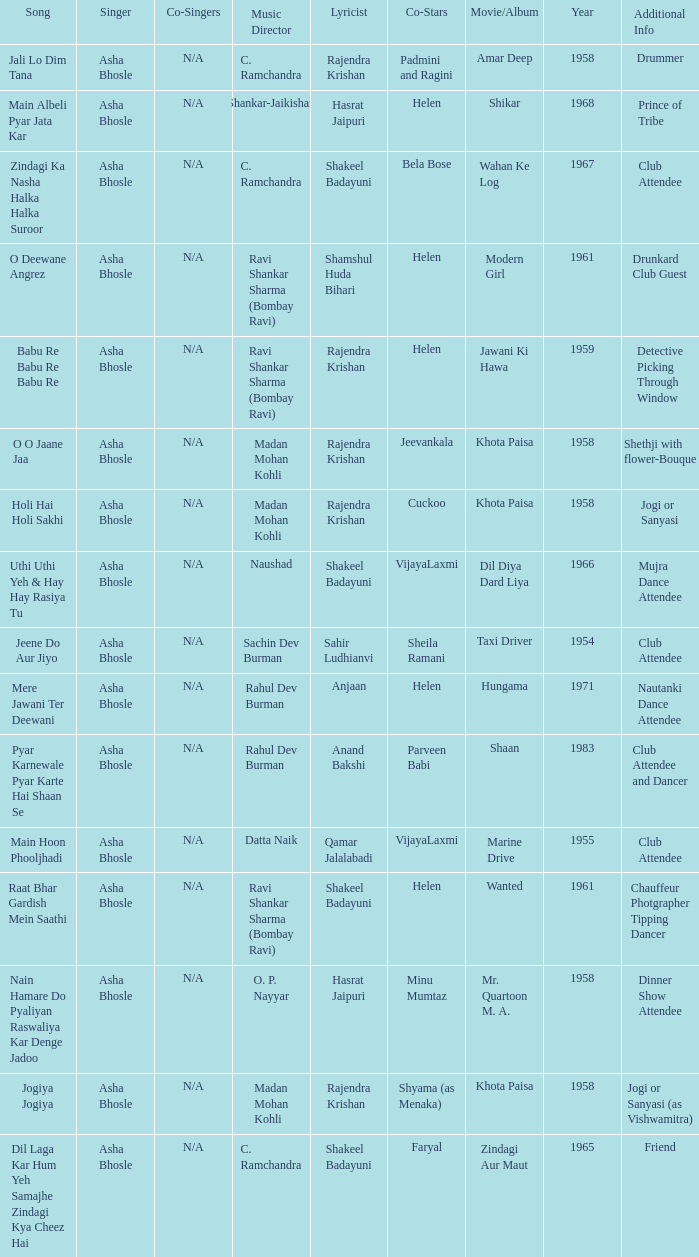What movie did Vijayalaxmi Co-star in and Shakeel Badayuni write the lyrics? Dil Diya Dard Liya. Parse the full table. {'header': ['Song', 'Singer', 'Co-Singers', 'Music Director', 'Lyricist', 'Co-Stars', 'Movie/Album', 'Year', 'Additional Info'], 'rows': [['Jali Lo Dim Tana', 'Asha Bhosle', 'N/A', 'C. Ramchandra', 'Rajendra Krishan', 'Padmini and Ragini', 'Amar Deep', '1958', 'Drummer'], ['Main Albeli Pyar Jata Kar', 'Asha Bhosle', 'N/A', 'Shankar-Jaikishan', 'Hasrat Jaipuri', 'Helen', 'Shikar', '1968', 'Prince of Tribe'], ['Zindagi Ka Nasha Halka Halka Suroor', 'Asha Bhosle', 'N/A', 'C. Ramchandra', 'Shakeel Badayuni', 'Bela Bose', 'Wahan Ke Log', '1967', 'Club Attendee'], ['O Deewane Angrez', 'Asha Bhosle', 'N/A', 'Ravi Shankar Sharma (Bombay Ravi)', 'Shamshul Huda Bihari', 'Helen', 'Modern Girl', '1961', 'Drunkard Club Guest'], ['Babu Re Babu Re Babu Re', 'Asha Bhosle', 'N/A', 'Ravi Shankar Sharma (Bombay Ravi)', 'Rajendra Krishan', 'Helen', 'Jawani Ki Hawa', '1959', 'Detective Picking Through Window'], ['O O Jaane Jaa', 'Asha Bhosle', 'N/A', 'Madan Mohan Kohli', 'Rajendra Krishan', 'Jeevankala', 'Khota Paisa', '1958', 'Shethji with flower-Bouque'], ['Holi Hai Holi Sakhi', 'Asha Bhosle', 'N/A', 'Madan Mohan Kohli', 'Rajendra Krishan', 'Cuckoo', 'Khota Paisa', '1958', 'Jogi or Sanyasi'], ['Uthi Uthi Yeh & Hay Hay Rasiya Tu', 'Asha Bhosle', 'N/A', 'Naushad', 'Shakeel Badayuni', 'VijayaLaxmi', 'Dil Diya Dard Liya', '1966', 'Mujra Dance Attendee'], ['Jeene Do Aur Jiyo', 'Asha Bhosle', 'N/A', 'Sachin Dev Burman', 'Sahir Ludhianvi', 'Sheila Ramani', 'Taxi Driver', '1954', 'Club Attendee'], ['Mere Jawani Ter Deewani', 'Asha Bhosle', 'N/A', 'Rahul Dev Burman', 'Anjaan', 'Helen', 'Hungama', '1971', 'Nautanki Dance Attendee'], ['Pyar Karnewale Pyar Karte Hai Shaan Se', 'Asha Bhosle', 'N/A', 'Rahul Dev Burman', 'Anand Bakshi', 'Parveen Babi', 'Shaan', '1983', 'Club Attendee and Dancer'], ['Main Hoon Phooljhadi', 'Asha Bhosle', 'N/A', 'Datta Naik', 'Qamar Jalalabadi', 'VijayaLaxmi', 'Marine Drive', '1955', 'Club Attendee'], ['Raat Bhar Gardish Mein Saathi', 'Asha Bhosle', 'N/A', 'Ravi Shankar Sharma (Bombay Ravi)', 'Shakeel Badayuni', 'Helen', 'Wanted', '1961', 'Chauffeur Photgrapher Tipping Dancer'], ['Nain Hamare Do Pyaliyan Raswaliya Kar Denge Jadoo', 'Asha Bhosle', 'N/A', 'O. P. Nayyar', 'Hasrat Jaipuri', 'Minu Mumtaz', 'Mr. Quartoon M. A.', '1958', 'Dinner Show Attendee'], ['Jogiya Jogiya', 'Asha Bhosle', 'N/A', 'Madan Mohan Kohli', 'Rajendra Krishan', 'Shyama (as Menaka)', 'Khota Paisa', '1958', 'Jogi or Sanyasi (as Vishwamitra)'], ['Dil Laga Kar Hum Yeh Samajhe Zindagi Kya Cheez Hai', 'Asha Bhosle', 'N/A', 'C. Ramchandra', 'Shakeel Badayuni', 'Faryal', 'Zindagi Aur Maut', '1965', 'Friend']]} 